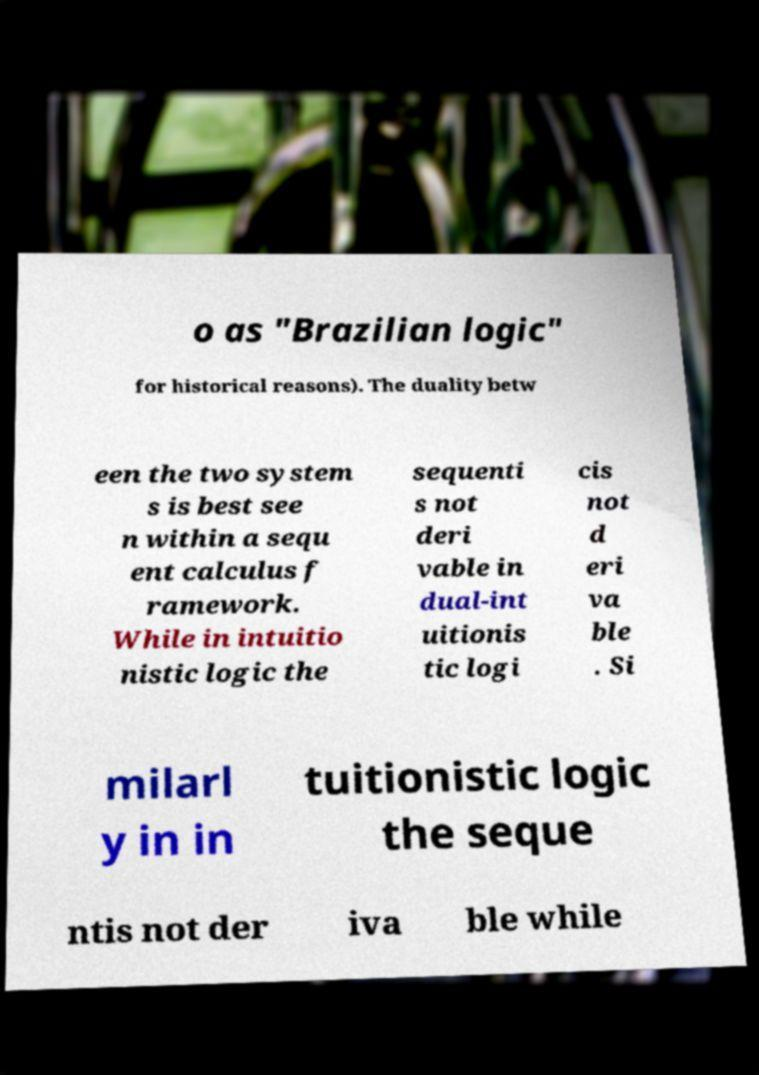I need the written content from this picture converted into text. Can you do that? o as "Brazilian logic" for historical reasons). The duality betw een the two system s is best see n within a sequ ent calculus f ramework. While in intuitio nistic logic the sequenti s not deri vable in dual-int uitionis tic logi cis not d eri va ble . Si milarl y in in tuitionistic logic the seque ntis not der iva ble while 